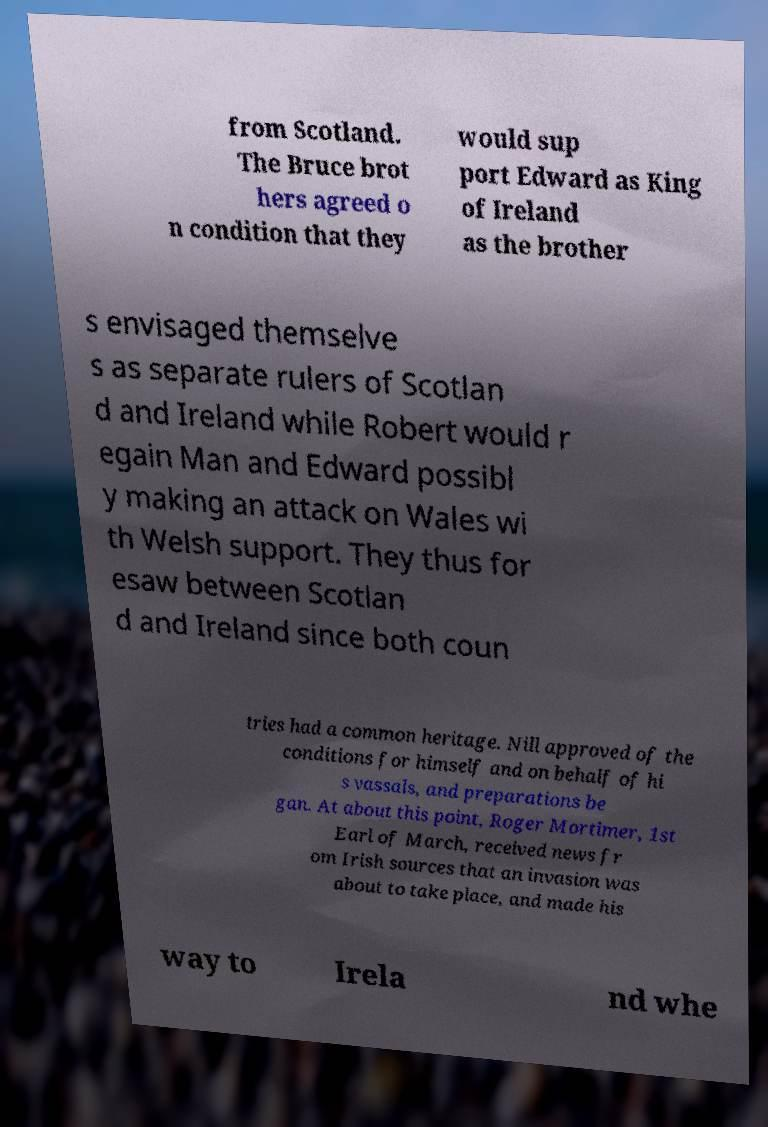Please read and relay the text visible in this image. What does it say? from Scotland. The Bruce brot hers agreed o n condition that they would sup port Edward as King of Ireland as the brother s envisaged themselve s as separate rulers of Scotlan d and Ireland while Robert would r egain Man and Edward possibl y making an attack on Wales wi th Welsh support. They thus for esaw between Scotlan d and Ireland since both coun tries had a common heritage. Nill approved of the conditions for himself and on behalf of hi s vassals, and preparations be gan. At about this point, Roger Mortimer, 1st Earl of March, received news fr om Irish sources that an invasion was about to take place, and made his way to Irela nd whe 